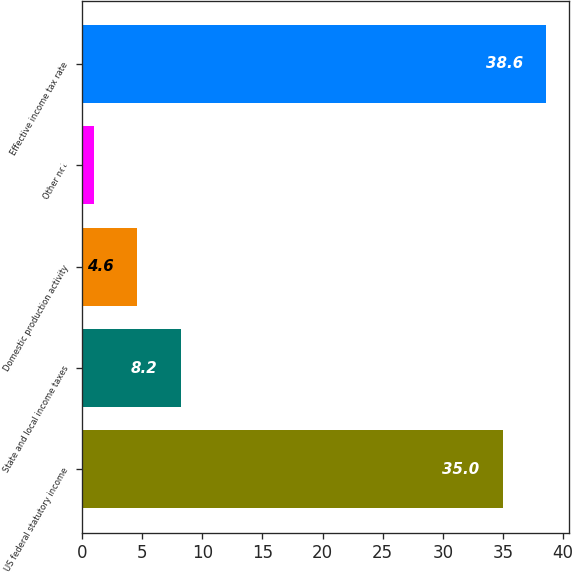<chart> <loc_0><loc_0><loc_500><loc_500><bar_chart><fcel>US federal statutory income<fcel>State and local income taxes<fcel>Domestic production activity<fcel>Other net<fcel>Effective income tax rate<nl><fcel>35<fcel>8.2<fcel>4.6<fcel>1<fcel>38.6<nl></chart> 